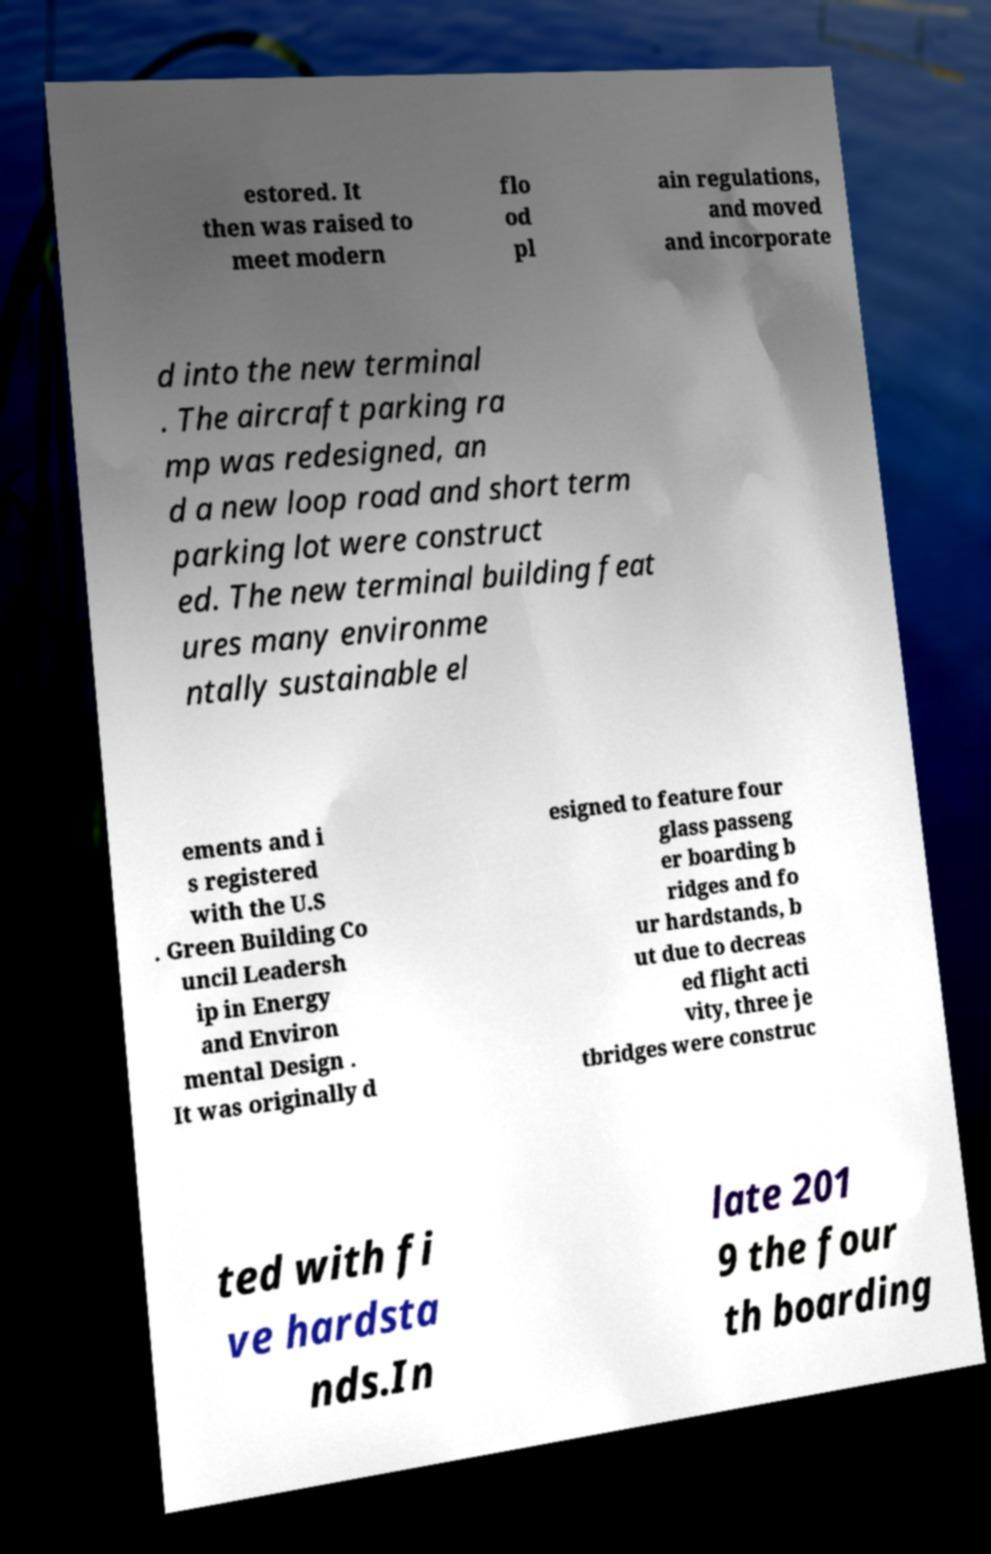Could you assist in decoding the text presented in this image and type it out clearly? estored. It then was raised to meet modern flo od pl ain regulations, and moved and incorporate d into the new terminal . The aircraft parking ra mp was redesigned, an d a new loop road and short term parking lot were construct ed. The new terminal building feat ures many environme ntally sustainable el ements and i s registered with the U.S . Green Building Co uncil Leadersh ip in Energy and Environ mental Design . It was originally d esigned to feature four glass passeng er boarding b ridges and fo ur hardstands, b ut due to decreas ed flight acti vity, three je tbridges were construc ted with fi ve hardsta nds.In late 201 9 the four th boarding 